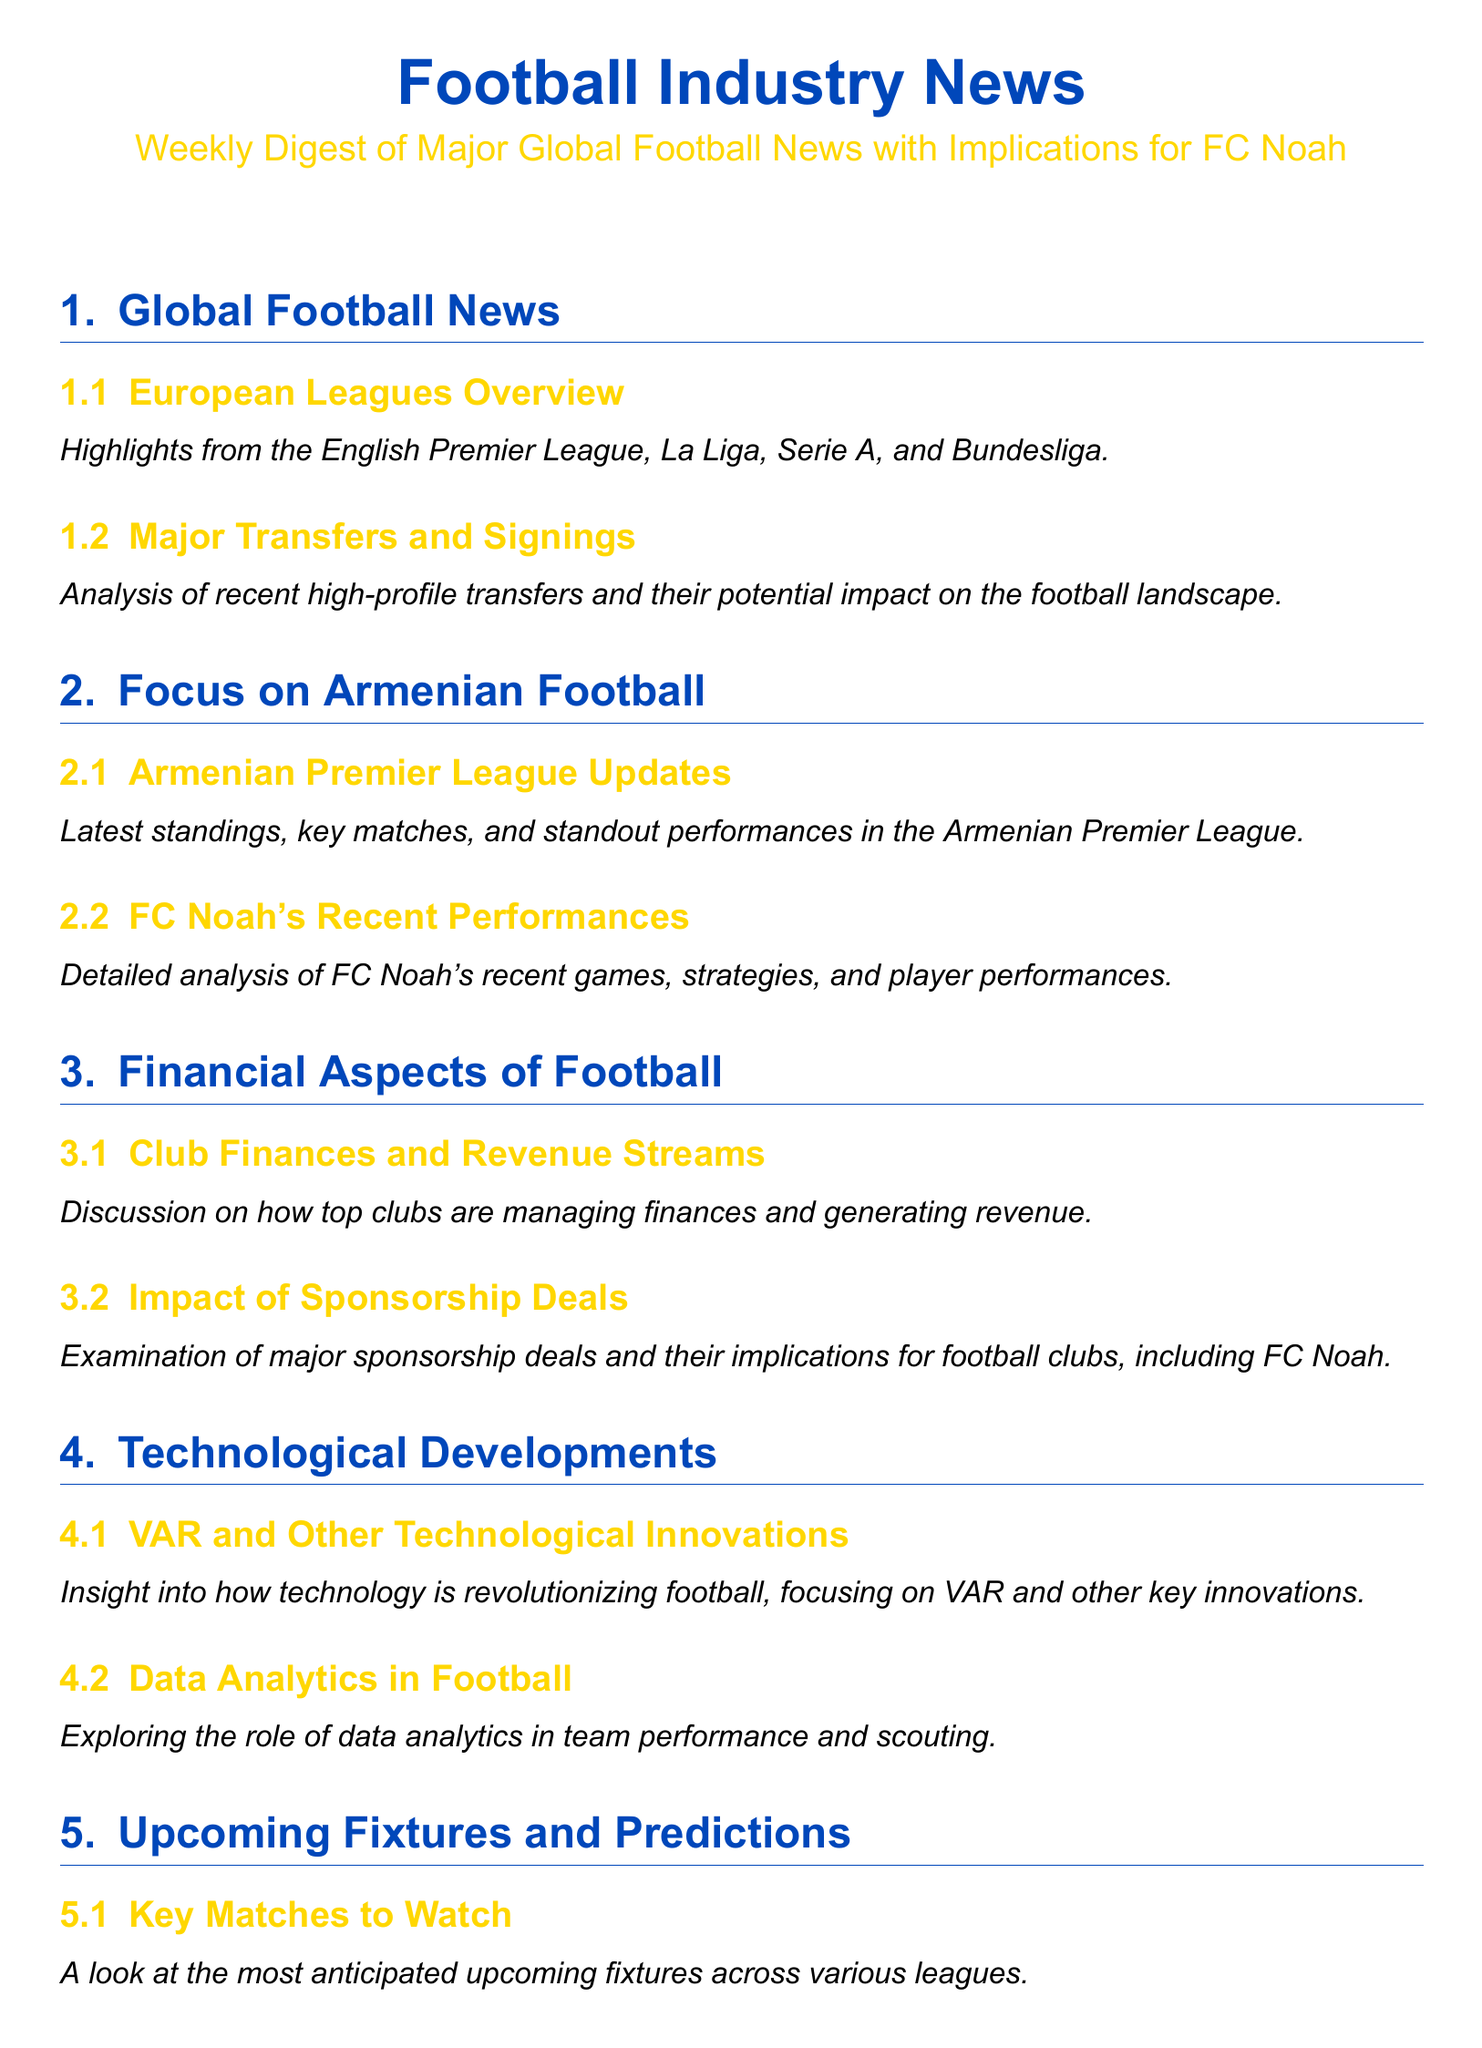What are the highlights from European leagues? The document lists the highlights from the English Premier League, La Liga, Serie A, and Bundesliga under the section "European Leagues Overview."
Answer: European Leagues Overview What is analyzed in the major transfers section? The section "Major Transfers and Signings" discusses the analysis of recent high-profile transfers and their potential impact on the football landscape.
Answer: Recent high-profile transfers What updates are provided in the Armenian Premier League section? The "Armenian Premier League Updates" subsection includes the latest standings, key matches, and standout performances.
Answer: Latest standings, key matches, standout performances What is included in the analysis of FC Noah's recent performances? The "FC Noah's Recent Performances" subsection offers a detailed analysis of FC Noah's recent games, strategies, and player performances.
Answer: Recent games, strategies, player performances What financial aspect discusses sponsorship deals? The subsection "Impact of Sponsorship Deals" examines major sponsorship deals and their implications for football clubs.
Answer: Major sponsorship deals Which section discusses technological innovations in football? Insights into how technology is revolutionizing football are provided in the "VAR and Other Technological Innovations" subsection.
Answer: VAR and Other Technological Innovations What do upcoming matches and predictions refer to? The "Key Matches to Watch" subsection addresses the most anticipated upcoming fixtures across various leagues.
Answer: Most anticipated upcoming fixtures What does the document say about FC Noah's next matches? The "FC Noah's Upcoming Games" subsection offers an overview and predictions for FC Noah's next matches.
Answer: Overview and predictions for FC Noah's next matches 